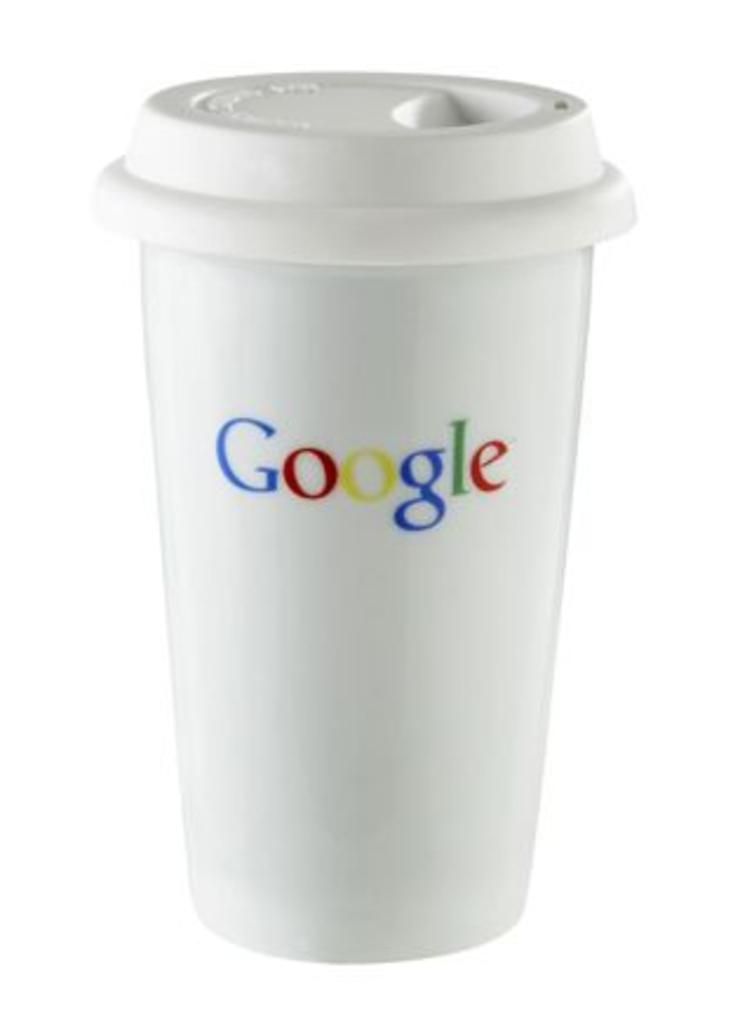Provide a one-sentence caption for the provided image. A white coffee cup with a lid has the Google logo on it. 